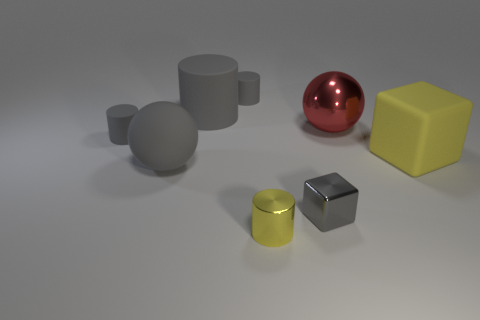Subtract all gray cylinders. How many were subtracted if there are1gray cylinders left? 2 Subtract all yellow cubes. How many gray cylinders are left? 3 Subtract 1 cylinders. How many cylinders are left? 3 Subtract all red cylinders. Subtract all purple blocks. How many cylinders are left? 4 Add 1 small shiny cylinders. How many objects exist? 9 Subtract all balls. How many objects are left? 6 Add 8 tiny metal cylinders. How many tiny metal cylinders exist? 9 Subtract 0 cyan spheres. How many objects are left? 8 Subtract all small shiny things. Subtract all small green shiny spheres. How many objects are left? 6 Add 8 yellow shiny objects. How many yellow shiny objects are left? 9 